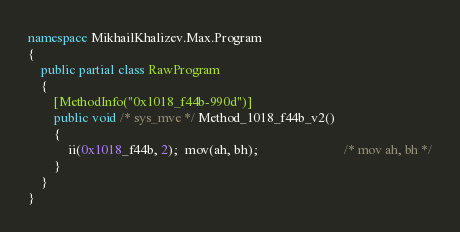<code> <loc_0><loc_0><loc_500><loc_500><_C#_>
namespace MikhailKhalizev.Max.Program
{
    public partial class RawProgram
    {
        [MethodInfo("0x1018_f44b-990d")]
        public void /* sys_mve */ Method_1018_f44b_v2()
        {
            ii(0x1018_f44b, 2);  mov(ah, bh);                          /* mov ah, bh */
        }
    }
}
</code> 